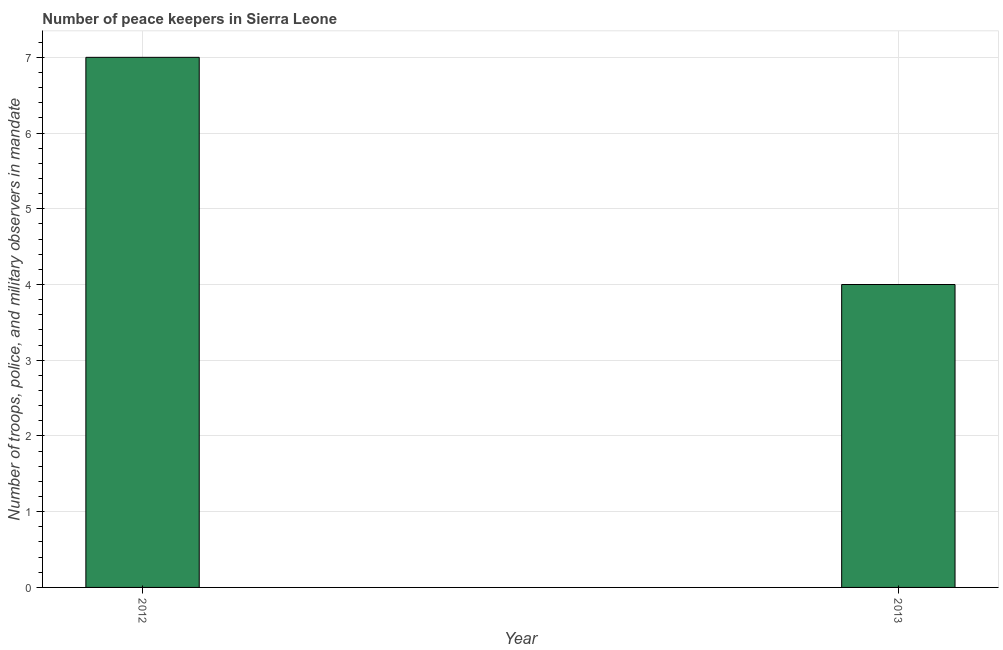Does the graph contain any zero values?
Your answer should be very brief. No. Does the graph contain grids?
Keep it short and to the point. Yes. What is the title of the graph?
Offer a terse response. Number of peace keepers in Sierra Leone. What is the label or title of the Y-axis?
Keep it short and to the point. Number of troops, police, and military observers in mandate. Across all years, what is the minimum number of peace keepers?
Give a very brief answer. 4. In which year was the number of peace keepers maximum?
Your response must be concise. 2012. What is the sum of the number of peace keepers?
Your answer should be compact. 11. What is the average number of peace keepers per year?
Offer a very short reply. 5. What is the median number of peace keepers?
Keep it short and to the point. 5.5. Do a majority of the years between 2013 and 2012 (inclusive) have number of peace keepers greater than 3.4 ?
Ensure brevity in your answer.  No. How many bars are there?
Ensure brevity in your answer.  2. What is the difference between two consecutive major ticks on the Y-axis?
Ensure brevity in your answer.  1. Are the values on the major ticks of Y-axis written in scientific E-notation?
Provide a succinct answer. No. What is the difference between the Number of troops, police, and military observers in mandate in 2012 and 2013?
Provide a succinct answer. 3. What is the ratio of the Number of troops, police, and military observers in mandate in 2012 to that in 2013?
Make the answer very short. 1.75. 